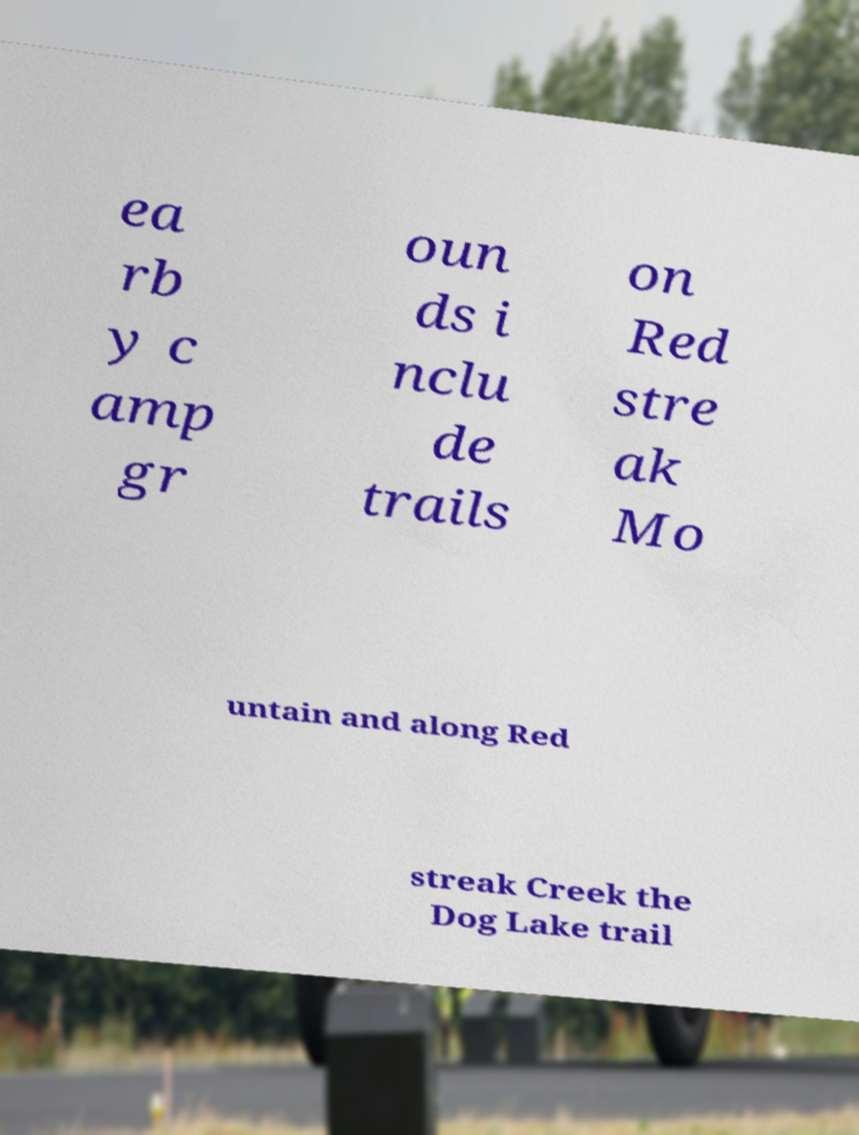Please read and relay the text visible in this image. What does it say? ea rb y c amp gr oun ds i nclu de trails on Red stre ak Mo untain and along Red streak Creek the Dog Lake trail 